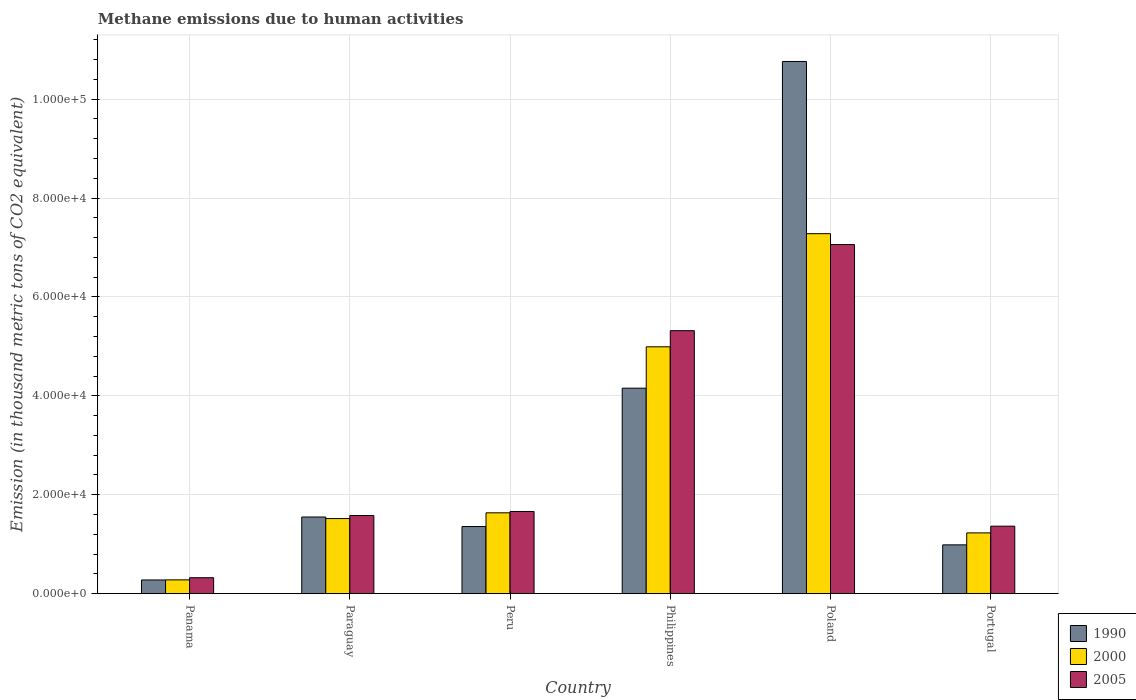Are the number of bars per tick equal to the number of legend labels?
Keep it short and to the point. Yes. What is the amount of methane emitted in 2005 in Panama?
Ensure brevity in your answer.  3225.9. Across all countries, what is the maximum amount of methane emitted in 2005?
Provide a succinct answer. 7.06e+04. Across all countries, what is the minimum amount of methane emitted in 2000?
Your answer should be compact. 2789.9. In which country was the amount of methane emitted in 2005 minimum?
Your answer should be compact. Panama. What is the total amount of methane emitted in 1990 in the graph?
Offer a very short reply. 1.91e+05. What is the difference between the amount of methane emitted in 2000 in Peru and that in Poland?
Provide a succinct answer. -5.64e+04. What is the difference between the amount of methane emitted in 2005 in Philippines and the amount of methane emitted in 2000 in Paraguay?
Offer a very short reply. 3.80e+04. What is the average amount of methane emitted in 2005 per country?
Keep it short and to the point. 2.88e+04. What is the difference between the amount of methane emitted of/in 2000 and amount of methane emitted of/in 1990 in Peru?
Your response must be concise. 2771.4. What is the ratio of the amount of methane emitted in 2000 in Poland to that in Portugal?
Keep it short and to the point. 5.92. Is the amount of methane emitted in 2000 in Paraguay less than that in Philippines?
Give a very brief answer. Yes. Is the difference between the amount of methane emitted in 2000 in Paraguay and Peru greater than the difference between the amount of methane emitted in 1990 in Paraguay and Peru?
Ensure brevity in your answer.  No. What is the difference between the highest and the second highest amount of methane emitted in 2005?
Give a very brief answer. 5.40e+04. What is the difference between the highest and the lowest amount of methane emitted in 2000?
Keep it short and to the point. 7.00e+04. Is the sum of the amount of methane emitted in 2000 in Poland and Portugal greater than the maximum amount of methane emitted in 1990 across all countries?
Provide a succinct answer. No. Is it the case that in every country, the sum of the amount of methane emitted in 2005 and amount of methane emitted in 2000 is greater than the amount of methane emitted in 1990?
Provide a short and direct response. Yes. How many bars are there?
Your answer should be compact. 18. Does the graph contain grids?
Provide a succinct answer. Yes. Where does the legend appear in the graph?
Provide a short and direct response. Bottom right. How are the legend labels stacked?
Keep it short and to the point. Vertical. What is the title of the graph?
Make the answer very short. Methane emissions due to human activities. Does "2011" appear as one of the legend labels in the graph?
Keep it short and to the point. No. What is the label or title of the Y-axis?
Give a very brief answer. Emission (in thousand metric tons of CO2 equivalent). What is the Emission (in thousand metric tons of CO2 equivalent) of 1990 in Panama?
Provide a succinct answer. 2769.4. What is the Emission (in thousand metric tons of CO2 equivalent) in 2000 in Panama?
Provide a succinct answer. 2789.9. What is the Emission (in thousand metric tons of CO2 equivalent) of 2005 in Panama?
Your answer should be compact. 3225.9. What is the Emission (in thousand metric tons of CO2 equivalent) in 1990 in Paraguay?
Offer a terse response. 1.55e+04. What is the Emission (in thousand metric tons of CO2 equivalent) in 2000 in Paraguay?
Keep it short and to the point. 1.52e+04. What is the Emission (in thousand metric tons of CO2 equivalent) in 2005 in Paraguay?
Your answer should be very brief. 1.58e+04. What is the Emission (in thousand metric tons of CO2 equivalent) in 1990 in Peru?
Provide a short and direct response. 1.36e+04. What is the Emission (in thousand metric tons of CO2 equivalent) of 2000 in Peru?
Your answer should be compact. 1.63e+04. What is the Emission (in thousand metric tons of CO2 equivalent) of 2005 in Peru?
Ensure brevity in your answer.  1.66e+04. What is the Emission (in thousand metric tons of CO2 equivalent) in 1990 in Philippines?
Make the answer very short. 4.16e+04. What is the Emission (in thousand metric tons of CO2 equivalent) in 2000 in Philippines?
Your answer should be very brief. 4.99e+04. What is the Emission (in thousand metric tons of CO2 equivalent) in 2005 in Philippines?
Make the answer very short. 5.32e+04. What is the Emission (in thousand metric tons of CO2 equivalent) of 1990 in Poland?
Your response must be concise. 1.08e+05. What is the Emission (in thousand metric tons of CO2 equivalent) of 2000 in Poland?
Make the answer very short. 7.28e+04. What is the Emission (in thousand metric tons of CO2 equivalent) in 2005 in Poland?
Give a very brief answer. 7.06e+04. What is the Emission (in thousand metric tons of CO2 equivalent) in 1990 in Portugal?
Offer a terse response. 9868.6. What is the Emission (in thousand metric tons of CO2 equivalent) in 2000 in Portugal?
Your answer should be very brief. 1.23e+04. What is the Emission (in thousand metric tons of CO2 equivalent) of 2005 in Portugal?
Offer a very short reply. 1.36e+04. Across all countries, what is the maximum Emission (in thousand metric tons of CO2 equivalent) in 1990?
Your answer should be very brief. 1.08e+05. Across all countries, what is the maximum Emission (in thousand metric tons of CO2 equivalent) in 2000?
Make the answer very short. 7.28e+04. Across all countries, what is the maximum Emission (in thousand metric tons of CO2 equivalent) of 2005?
Provide a succinct answer. 7.06e+04. Across all countries, what is the minimum Emission (in thousand metric tons of CO2 equivalent) of 1990?
Your answer should be very brief. 2769.4. Across all countries, what is the minimum Emission (in thousand metric tons of CO2 equivalent) of 2000?
Provide a succinct answer. 2789.9. Across all countries, what is the minimum Emission (in thousand metric tons of CO2 equivalent) of 2005?
Your response must be concise. 3225.9. What is the total Emission (in thousand metric tons of CO2 equivalent) in 1990 in the graph?
Offer a very short reply. 1.91e+05. What is the total Emission (in thousand metric tons of CO2 equivalent) in 2000 in the graph?
Your answer should be compact. 1.69e+05. What is the total Emission (in thousand metric tons of CO2 equivalent) of 2005 in the graph?
Ensure brevity in your answer.  1.73e+05. What is the difference between the Emission (in thousand metric tons of CO2 equivalent) of 1990 in Panama and that in Paraguay?
Your answer should be compact. -1.27e+04. What is the difference between the Emission (in thousand metric tons of CO2 equivalent) in 2000 in Panama and that in Paraguay?
Give a very brief answer. -1.24e+04. What is the difference between the Emission (in thousand metric tons of CO2 equivalent) of 2005 in Panama and that in Paraguay?
Provide a succinct answer. -1.26e+04. What is the difference between the Emission (in thousand metric tons of CO2 equivalent) of 1990 in Panama and that in Peru?
Ensure brevity in your answer.  -1.08e+04. What is the difference between the Emission (in thousand metric tons of CO2 equivalent) of 2000 in Panama and that in Peru?
Offer a terse response. -1.36e+04. What is the difference between the Emission (in thousand metric tons of CO2 equivalent) in 2005 in Panama and that in Peru?
Provide a short and direct response. -1.34e+04. What is the difference between the Emission (in thousand metric tons of CO2 equivalent) of 1990 in Panama and that in Philippines?
Your answer should be compact. -3.88e+04. What is the difference between the Emission (in thousand metric tons of CO2 equivalent) of 2000 in Panama and that in Philippines?
Provide a succinct answer. -4.71e+04. What is the difference between the Emission (in thousand metric tons of CO2 equivalent) in 2005 in Panama and that in Philippines?
Offer a terse response. -4.99e+04. What is the difference between the Emission (in thousand metric tons of CO2 equivalent) in 1990 in Panama and that in Poland?
Make the answer very short. -1.05e+05. What is the difference between the Emission (in thousand metric tons of CO2 equivalent) in 2000 in Panama and that in Poland?
Give a very brief answer. -7.00e+04. What is the difference between the Emission (in thousand metric tons of CO2 equivalent) of 2005 in Panama and that in Poland?
Your answer should be compact. -6.74e+04. What is the difference between the Emission (in thousand metric tons of CO2 equivalent) in 1990 in Panama and that in Portugal?
Ensure brevity in your answer.  -7099.2. What is the difference between the Emission (in thousand metric tons of CO2 equivalent) of 2000 in Panama and that in Portugal?
Provide a short and direct response. -9499.2. What is the difference between the Emission (in thousand metric tons of CO2 equivalent) in 2005 in Panama and that in Portugal?
Offer a very short reply. -1.04e+04. What is the difference between the Emission (in thousand metric tons of CO2 equivalent) in 1990 in Paraguay and that in Peru?
Give a very brief answer. 1927.1. What is the difference between the Emission (in thousand metric tons of CO2 equivalent) of 2000 in Paraguay and that in Peru?
Make the answer very short. -1160.8. What is the difference between the Emission (in thousand metric tons of CO2 equivalent) in 2005 in Paraguay and that in Peru?
Give a very brief answer. -820.6. What is the difference between the Emission (in thousand metric tons of CO2 equivalent) in 1990 in Paraguay and that in Philippines?
Give a very brief answer. -2.61e+04. What is the difference between the Emission (in thousand metric tons of CO2 equivalent) of 2000 in Paraguay and that in Philippines?
Provide a succinct answer. -3.47e+04. What is the difference between the Emission (in thousand metric tons of CO2 equivalent) in 2005 in Paraguay and that in Philippines?
Your response must be concise. -3.74e+04. What is the difference between the Emission (in thousand metric tons of CO2 equivalent) in 1990 in Paraguay and that in Poland?
Provide a short and direct response. -9.21e+04. What is the difference between the Emission (in thousand metric tons of CO2 equivalent) in 2000 in Paraguay and that in Poland?
Give a very brief answer. -5.76e+04. What is the difference between the Emission (in thousand metric tons of CO2 equivalent) in 2005 in Paraguay and that in Poland?
Ensure brevity in your answer.  -5.48e+04. What is the difference between the Emission (in thousand metric tons of CO2 equivalent) in 1990 in Paraguay and that in Portugal?
Keep it short and to the point. 5632.2. What is the difference between the Emission (in thousand metric tons of CO2 equivalent) of 2000 in Paraguay and that in Portugal?
Offer a very short reply. 2895.2. What is the difference between the Emission (in thousand metric tons of CO2 equivalent) in 2005 in Paraguay and that in Portugal?
Make the answer very short. 2151.5. What is the difference between the Emission (in thousand metric tons of CO2 equivalent) in 1990 in Peru and that in Philippines?
Your answer should be very brief. -2.80e+04. What is the difference between the Emission (in thousand metric tons of CO2 equivalent) in 2000 in Peru and that in Philippines?
Keep it short and to the point. -3.36e+04. What is the difference between the Emission (in thousand metric tons of CO2 equivalent) of 2005 in Peru and that in Philippines?
Your answer should be very brief. -3.66e+04. What is the difference between the Emission (in thousand metric tons of CO2 equivalent) of 1990 in Peru and that in Poland?
Make the answer very short. -9.40e+04. What is the difference between the Emission (in thousand metric tons of CO2 equivalent) of 2000 in Peru and that in Poland?
Provide a succinct answer. -5.64e+04. What is the difference between the Emission (in thousand metric tons of CO2 equivalent) in 2005 in Peru and that in Poland?
Provide a short and direct response. -5.40e+04. What is the difference between the Emission (in thousand metric tons of CO2 equivalent) of 1990 in Peru and that in Portugal?
Offer a very short reply. 3705.1. What is the difference between the Emission (in thousand metric tons of CO2 equivalent) of 2000 in Peru and that in Portugal?
Your response must be concise. 4056. What is the difference between the Emission (in thousand metric tons of CO2 equivalent) of 2005 in Peru and that in Portugal?
Make the answer very short. 2972.1. What is the difference between the Emission (in thousand metric tons of CO2 equivalent) of 1990 in Philippines and that in Poland?
Offer a terse response. -6.61e+04. What is the difference between the Emission (in thousand metric tons of CO2 equivalent) in 2000 in Philippines and that in Poland?
Make the answer very short. -2.29e+04. What is the difference between the Emission (in thousand metric tons of CO2 equivalent) in 2005 in Philippines and that in Poland?
Provide a succinct answer. -1.74e+04. What is the difference between the Emission (in thousand metric tons of CO2 equivalent) of 1990 in Philippines and that in Portugal?
Make the answer very short. 3.17e+04. What is the difference between the Emission (in thousand metric tons of CO2 equivalent) in 2000 in Philippines and that in Portugal?
Your response must be concise. 3.76e+04. What is the difference between the Emission (in thousand metric tons of CO2 equivalent) of 2005 in Philippines and that in Portugal?
Your response must be concise. 3.95e+04. What is the difference between the Emission (in thousand metric tons of CO2 equivalent) of 1990 in Poland and that in Portugal?
Your response must be concise. 9.77e+04. What is the difference between the Emission (in thousand metric tons of CO2 equivalent) of 2000 in Poland and that in Portugal?
Your answer should be compact. 6.05e+04. What is the difference between the Emission (in thousand metric tons of CO2 equivalent) of 2005 in Poland and that in Portugal?
Offer a terse response. 5.69e+04. What is the difference between the Emission (in thousand metric tons of CO2 equivalent) in 1990 in Panama and the Emission (in thousand metric tons of CO2 equivalent) in 2000 in Paraguay?
Your response must be concise. -1.24e+04. What is the difference between the Emission (in thousand metric tons of CO2 equivalent) of 1990 in Panama and the Emission (in thousand metric tons of CO2 equivalent) of 2005 in Paraguay?
Your response must be concise. -1.30e+04. What is the difference between the Emission (in thousand metric tons of CO2 equivalent) in 2000 in Panama and the Emission (in thousand metric tons of CO2 equivalent) in 2005 in Paraguay?
Your answer should be compact. -1.30e+04. What is the difference between the Emission (in thousand metric tons of CO2 equivalent) of 1990 in Panama and the Emission (in thousand metric tons of CO2 equivalent) of 2000 in Peru?
Your answer should be very brief. -1.36e+04. What is the difference between the Emission (in thousand metric tons of CO2 equivalent) of 1990 in Panama and the Emission (in thousand metric tons of CO2 equivalent) of 2005 in Peru?
Offer a very short reply. -1.38e+04. What is the difference between the Emission (in thousand metric tons of CO2 equivalent) of 2000 in Panama and the Emission (in thousand metric tons of CO2 equivalent) of 2005 in Peru?
Your response must be concise. -1.38e+04. What is the difference between the Emission (in thousand metric tons of CO2 equivalent) of 1990 in Panama and the Emission (in thousand metric tons of CO2 equivalent) of 2000 in Philippines?
Give a very brief answer. -4.71e+04. What is the difference between the Emission (in thousand metric tons of CO2 equivalent) of 1990 in Panama and the Emission (in thousand metric tons of CO2 equivalent) of 2005 in Philippines?
Make the answer very short. -5.04e+04. What is the difference between the Emission (in thousand metric tons of CO2 equivalent) of 2000 in Panama and the Emission (in thousand metric tons of CO2 equivalent) of 2005 in Philippines?
Keep it short and to the point. -5.04e+04. What is the difference between the Emission (in thousand metric tons of CO2 equivalent) of 1990 in Panama and the Emission (in thousand metric tons of CO2 equivalent) of 2000 in Poland?
Your answer should be very brief. -7.00e+04. What is the difference between the Emission (in thousand metric tons of CO2 equivalent) of 1990 in Panama and the Emission (in thousand metric tons of CO2 equivalent) of 2005 in Poland?
Give a very brief answer. -6.78e+04. What is the difference between the Emission (in thousand metric tons of CO2 equivalent) of 2000 in Panama and the Emission (in thousand metric tons of CO2 equivalent) of 2005 in Poland?
Offer a very short reply. -6.78e+04. What is the difference between the Emission (in thousand metric tons of CO2 equivalent) in 1990 in Panama and the Emission (in thousand metric tons of CO2 equivalent) in 2000 in Portugal?
Offer a very short reply. -9519.7. What is the difference between the Emission (in thousand metric tons of CO2 equivalent) in 1990 in Panama and the Emission (in thousand metric tons of CO2 equivalent) in 2005 in Portugal?
Make the answer very short. -1.09e+04. What is the difference between the Emission (in thousand metric tons of CO2 equivalent) of 2000 in Panama and the Emission (in thousand metric tons of CO2 equivalent) of 2005 in Portugal?
Offer a very short reply. -1.09e+04. What is the difference between the Emission (in thousand metric tons of CO2 equivalent) of 1990 in Paraguay and the Emission (in thousand metric tons of CO2 equivalent) of 2000 in Peru?
Make the answer very short. -844.3. What is the difference between the Emission (in thousand metric tons of CO2 equivalent) in 1990 in Paraguay and the Emission (in thousand metric tons of CO2 equivalent) in 2005 in Peru?
Offer a terse response. -1118.2. What is the difference between the Emission (in thousand metric tons of CO2 equivalent) of 2000 in Paraguay and the Emission (in thousand metric tons of CO2 equivalent) of 2005 in Peru?
Provide a short and direct response. -1434.7. What is the difference between the Emission (in thousand metric tons of CO2 equivalent) in 1990 in Paraguay and the Emission (in thousand metric tons of CO2 equivalent) in 2000 in Philippines?
Keep it short and to the point. -3.44e+04. What is the difference between the Emission (in thousand metric tons of CO2 equivalent) in 1990 in Paraguay and the Emission (in thousand metric tons of CO2 equivalent) in 2005 in Philippines?
Offer a terse response. -3.77e+04. What is the difference between the Emission (in thousand metric tons of CO2 equivalent) of 2000 in Paraguay and the Emission (in thousand metric tons of CO2 equivalent) of 2005 in Philippines?
Your response must be concise. -3.80e+04. What is the difference between the Emission (in thousand metric tons of CO2 equivalent) of 1990 in Paraguay and the Emission (in thousand metric tons of CO2 equivalent) of 2000 in Poland?
Ensure brevity in your answer.  -5.73e+04. What is the difference between the Emission (in thousand metric tons of CO2 equivalent) of 1990 in Paraguay and the Emission (in thousand metric tons of CO2 equivalent) of 2005 in Poland?
Keep it short and to the point. -5.51e+04. What is the difference between the Emission (in thousand metric tons of CO2 equivalent) of 2000 in Paraguay and the Emission (in thousand metric tons of CO2 equivalent) of 2005 in Poland?
Your answer should be very brief. -5.54e+04. What is the difference between the Emission (in thousand metric tons of CO2 equivalent) of 1990 in Paraguay and the Emission (in thousand metric tons of CO2 equivalent) of 2000 in Portugal?
Ensure brevity in your answer.  3211.7. What is the difference between the Emission (in thousand metric tons of CO2 equivalent) of 1990 in Paraguay and the Emission (in thousand metric tons of CO2 equivalent) of 2005 in Portugal?
Provide a short and direct response. 1853.9. What is the difference between the Emission (in thousand metric tons of CO2 equivalent) in 2000 in Paraguay and the Emission (in thousand metric tons of CO2 equivalent) in 2005 in Portugal?
Your answer should be very brief. 1537.4. What is the difference between the Emission (in thousand metric tons of CO2 equivalent) of 1990 in Peru and the Emission (in thousand metric tons of CO2 equivalent) of 2000 in Philippines?
Provide a short and direct response. -3.63e+04. What is the difference between the Emission (in thousand metric tons of CO2 equivalent) of 1990 in Peru and the Emission (in thousand metric tons of CO2 equivalent) of 2005 in Philippines?
Offer a terse response. -3.96e+04. What is the difference between the Emission (in thousand metric tons of CO2 equivalent) of 2000 in Peru and the Emission (in thousand metric tons of CO2 equivalent) of 2005 in Philippines?
Ensure brevity in your answer.  -3.68e+04. What is the difference between the Emission (in thousand metric tons of CO2 equivalent) in 1990 in Peru and the Emission (in thousand metric tons of CO2 equivalent) in 2000 in Poland?
Offer a terse response. -5.92e+04. What is the difference between the Emission (in thousand metric tons of CO2 equivalent) of 1990 in Peru and the Emission (in thousand metric tons of CO2 equivalent) of 2005 in Poland?
Your answer should be very brief. -5.70e+04. What is the difference between the Emission (in thousand metric tons of CO2 equivalent) of 2000 in Peru and the Emission (in thousand metric tons of CO2 equivalent) of 2005 in Poland?
Provide a succinct answer. -5.42e+04. What is the difference between the Emission (in thousand metric tons of CO2 equivalent) of 1990 in Peru and the Emission (in thousand metric tons of CO2 equivalent) of 2000 in Portugal?
Your response must be concise. 1284.6. What is the difference between the Emission (in thousand metric tons of CO2 equivalent) of 1990 in Peru and the Emission (in thousand metric tons of CO2 equivalent) of 2005 in Portugal?
Your response must be concise. -73.2. What is the difference between the Emission (in thousand metric tons of CO2 equivalent) of 2000 in Peru and the Emission (in thousand metric tons of CO2 equivalent) of 2005 in Portugal?
Offer a very short reply. 2698.2. What is the difference between the Emission (in thousand metric tons of CO2 equivalent) in 1990 in Philippines and the Emission (in thousand metric tons of CO2 equivalent) in 2000 in Poland?
Your response must be concise. -3.12e+04. What is the difference between the Emission (in thousand metric tons of CO2 equivalent) of 1990 in Philippines and the Emission (in thousand metric tons of CO2 equivalent) of 2005 in Poland?
Provide a short and direct response. -2.90e+04. What is the difference between the Emission (in thousand metric tons of CO2 equivalent) in 2000 in Philippines and the Emission (in thousand metric tons of CO2 equivalent) in 2005 in Poland?
Your answer should be compact. -2.07e+04. What is the difference between the Emission (in thousand metric tons of CO2 equivalent) in 1990 in Philippines and the Emission (in thousand metric tons of CO2 equivalent) in 2000 in Portugal?
Provide a succinct answer. 2.93e+04. What is the difference between the Emission (in thousand metric tons of CO2 equivalent) of 1990 in Philippines and the Emission (in thousand metric tons of CO2 equivalent) of 2005 in Portugal?
Your answer should be compact. 2.79e+04. What is the difference between the Emission (in thousand metric tons of CO2 equivalent) in 2000 in Philippines and the Emission (in thousand metric tons of CO2 equivalent) in 2005 in Portugal?
Offer a terse response. 3.63e+04. What is the difference between the Emission (in thousand metric tons of CO2 equivalent) of 1990 in Poland and the Emission (in thousand metric tons of CO2 equivalent) of 2000 in Portugal?
Your answer should be very brief. 9.53e+04. What is the difference between the Emission (in thousand metric tons of CO2 equivalent) of 1990 in Poland and the Emission (in thousand metric tons of CO2 equivalent) of 2005 in Portugal?
Your answer should be very brief. 9.40e+04. What is the difference between the Emission (in thousand metric tons of CO2 equivalent) of 2000 in Poland and the Emission (in thousand metric tons of CO2 equivalent) of 2005 in Portugal?
Your response must be concise. 5.91e+04. What is the average Emission (in thousand metric tons of CO2 equivalent) in 1990 per country?
Your answer should be very brief. 3.18e+04. What is the average Emission (in thousand metric tons of CO2 equivalent) in 2000 per country?
Offer a terse response. 2.82e+04. What is the average Emission (in thousand metric tons of CO2 equivalent) in 2005 per country?
Provide a succinct answer. 2.88e+04. What is the difference between the Emission (in thousand metric tons of CO2 equivalent) of 1990 and Emission (in thousand metric tons of CO2 equivalent) of 2000 in Panama?
Make the answer very short. -20.5. What is the difference between the Emission (in thousand metric tons of CO2 equivalent) of 1990 and Emission (in thousand metric tons of CO2 equivalent) of 2005 in Panama?
Offer a very short reply. -456.5. What is the difference between the Emission (in thousand metric tons of CO2 equivalent) in 2000 and Emission (in thousand metric tons of CO2 equivalent) in 2005 in Panama?
Your response must be concise. -436. What is the difference between the Emission (in thousand metric tons of CO2 equivalent) of 1990 and Emission (in thousand metric tons of CO2 equivalent) of 2000 in Paraguay?
Your response must be concise. 316.5. What is the difference between the Emission (in thousand metric tons of CO2 equivalent) in 1990 and Emission (in thousand metric tons of CO2 equivalent) in 2005 in Paraguay?
Provide a short and direct response. -297.6. What is the difference between the Emission (in thousand metric tons of CO2 equivalent) of 2000 and Emission (in thousand metric tons of CO2 equivalent) of 2005 in Paraguay?
Your answer should be compact. -614.1. What is the difference between the Emission (in thousand metric tons of CO2 equivalent) in 1990 and Emission (in thousand metric tons of CO2 equivalent) in 2000 in Peru?
Provide a short and direct response. -2771.4. What is the difference between the Emission (in thousand metric tons of CO2 equivalent) of 1990 and Emission (in thousand metric tons of CO2 equivalent) of 2005 in Peru?
Give a very brief answer. -3045.3. What is the difference between the Emission (in thousand metric tons of CO2 equivalent) in 2000 and Emission (in thousand metric tons of CO2 equivalent) in 2005 in Peru?
Your answer should be compact. -273.9. What is the difference between the Emission (in thousand metric tons of CO2 equivalent) in 1990 and Emission (in thousand metric tons of CO2 equivalent) in 2000 in Philippines?
Ensure brevity in your answer.  -8363.6. What is the difference between the Emission (in thousand metric tons of CO2 equivalent) of 1990 and Emission (in thousand metric tons of CO2 equivalent) of 2005 in Philippines?
Your answer should be very brief. -1.16e+04. What is the difference between the Emission (in thousand metric tons of CO2 equivalent) in 2000 and Emission (in thousand metric tons of CO2 equivalent) in 2005 in Philippines?
Provide a short and direct response. -3260.6. What is the difference between the Emission (in thousand metric tons of CO2 equivalent) of 1990 and Emission (in thousand metric tons of CO2 equivalent) of 2000 in Poland?
Provide a short and direct response. 3.48e+04. What is the difference between the Emission (in thousand metric tons of CO2 equivalent) in 1990 and Emission (in thousand metric tons of CO2 equivalent) in 2005 in Poland?
Provide a succinct answer. 3.70e+04. What is the difference between the Emission (in thousand metric tons of CO2 equivalent) of 2000 and Emission (in thousand metric tons of CO2 equivalent) of 2005 in Poland?
Ensure brevity in your answer.  2197.9. What is the difference between the Emission (in thousand metric tons of CO2 equivalent) in 1990 and Emission (in thousand metric tons of CO2 equivalent) in 2000 in Portugal?
Your answer should be very brief. -2420.5. What is the difference between the Emission (in thousand metric tons of CO2 equivalent) of 1990 and Emission (in thousand metric tons of CO2 equivalent) of 2005 in Portugal?
Provide a short and direct response. -3778.3. What is the difference between the Emission (in thousand metric tons of CO2 equivalent) in 2000 and Emission (in thousand metric tons of CO2 equivalent) in 2005 in Portugal?
Your response must be concise. -1357.8. What is the ratio of the Emission (in thousand metric tons of CO2 equivalent) of 1990 in Panama to that in Paraguay?
Provide a short and direct response. 0.18. What is the ratio of the Emission (in thousand metric tons of CO2 equivalent) in 2000 in Panama to that in Paraguay?
Offer a terse response. 0.18. What is the ratio of the Emission (in thousand metric tons of CO2 equivalent) in 2005 in Panama to that in Paraguay?
Your answer should be compact. 0.2. What is the ratio of the Emission (in thousand metric tons of CO2 equivalent) in 1990 in Panama to that in Peru?
Offer a very short reply. 0.2. What is the ratio of the Emission (in thousand metric tons of CO2 equivalent) in 2000 in Panama to that in Peru?
Ensure brevity in your answer.  0.17. What is the ratio of the Emission (in thousand metric tons of CO2 equivalent) of 2005 in Panama to that in Peru?
Offer a very short reply. 0.19. What is the ratio of the Emission (in thousand metric tons of CO2 equivalent) in 1990 in Panama to that in Philippines?
Provide a short and direct response. 0.07. What is the ratio of the Emission (in thousand metric tons of CO2 equivalent) of 2000 in Panama to that in Philippines?
Offer a terse response. 0.06. What is the ratio of the Emission (in thousand metric tons of CO2 equivalent) of 2005 in Panama to that in Philippines?
Keep it short and to the point. 0.06. What is the ratio of the Emission (in thousand metric tons of CO2 equivalent) of 1990 in Panama to that in Poland?
Keep it short and to the point. 0.03. What is the ratio of the Emission (in thousand metric tons of CO2 equivalent) in 2000 in Panama to that in Poland?
Your answer should be compact. 0.04. What is the ratio of the Emission (in thousand metric tons of CO2 equivalent) in 2005 in Panama to that in Poland?
Provide a short and direct response. 0.05. What is the ratio of the Emission (in thousand metric tons of CO2 equivalent) of 1990 in Panama to that in Portugal?
Offer a terse response. 0.28. What is the ratio of the Emission (in thousand metric tons of CO2 equivalent) of 2000 in Panama to that in Portugal?
Keep it short and to the point. 0.23. What is the ratio of the Emission (in thousand metric tons of CO2 equivalent) of 2005 in Panama to that in Portugal?
Offer a terse response. 0.24. What is the ratio of the Emission (in thousand metric tons of CO2 equivalent) in 1990 in Paraguay to that in Peru?
Ensure brevity in your answer.  1.14. What is the ratio of the Emission (in thousand metric tons of CO2 equivalent) in 2000 in Paraguay to that in Peru?
Your response must be concise. 0.93. What is the ratio of the Emission (in thousand metric tons of CO2 equivalent) of 2005 in Paraguay to that in Peru?
Your answer should be compact. 0.95. What is the ratio of the Emission (in thousand metric tons of CO2 equivalent) of 1990 in Paraguay to that in Philippines?
Give a very brief answer. 0.37. What is the ratio of the Emission (in thousand metric tons of CO2 equivalent) in 2000 in Paraguay to that in Philippines?
Offer a very short reply. 0.3. What is the ratio of the Emission (in thousand metric tons of CO2 equivalent) in 2005 in Paraguay to that in Philippines?
Offer a terse response. 0.3. What is the ratio of the Emission (in thousand metric tons of CO2 equivalent) in 1990 in Paraguay to that in Poland?
Your response must be concise. 0.14. What is the ratio of the Emission (in thousand metric tons of CO2 equivalent) of 2000 in Paraguay to that in Poland?
Give a very brief answer. 0.21. What is the ratio of the Emission (in thousand metric tons of CO2 equivalent) in 2005 in Paraguay to that in Poland?
Your response must be concise. 0.22. What is the ratio of the Emission (in thousand metric tons of CO2 equivalent) in 1990 in Paraguay to that in Portugal?
Make the answer very short. 1.57. What is the ratio of the Emission (in thousand metric tons of CO2 equivalent) of 2000 in Paraguay to that in Portugal?
Provide a short and direct response. 1.24. What is the ratio of the Emission (in thousand metric tons of CO2 equivalent) in 2005 in Paraguay to that in Portugal?
Offer a terse response. 1.16. What is the ratio of the Emission (in thousand metric tons of CO2 equivalent) in 1990 in Peru to that in Philippines?
Provide a succinct answer. 0.33. What is the ratio of the Emission (in thousand metric tons of CO2 equivalent) of 2000 in Peru to that in Philippines?
Provide a succinct answer. 0.33. What is the ratio of the Emission (in thousand metric tons of CO2 equivalent) of 2005 in Peru to that in Philippines?
Make the answer very short. 0.31. What is the ratio of the Emission (in thousand metric tons of CO2 equivalent) in 1990 in Peru to that in Poland?
Your answer should be very brief. 0.13. What is the ratio of the Emission (in thousand metric tons of CO2 equivalent) in 2000 in Peru to that in Poland?
Give a very brief answer. 0.22. What is the ratio of the Emission (in thousand metric tons of CO2 equivalent) of 2005 in Peru to that in Poland?
Offer a very short reply. 0.24. What is the ratio of the Emission (in thousand metric tons of CO2 equivalent) in 1990 in Peru to that in Portugal?
Your response must be concise. 1.38. What is the ratio of the Emission (in thousand metric tons of CO2 equivalent) of 2000 in Peru to that in Portugal?
Your answer should be very brief. 1.33. What is the ratio of the Emission (in thousand metric tons of CO2 equivalent) of 2005 in Peru to that in Portugal?
Ensure brevity in your answer.  1.22. What is the ratio of the Emission (in thousand metric tons of CO2 equivalent) of 1990 in Philippines to that in Poland?
Your answer should be compact. 0.39. What is the ratio of the Emission (in thousand metric tons of CO2 equivalent) in 2000 in Philippines to that in Poland?
Provide a succinct answer. 0.69. What is the ratio of the Emission (in thousand metric tons of CO2 equivalent) in 2005 in Philippines to that in Poland?
Provide a succinct answer. 0.75. What is the ratio of the Emission (in thousand metric tons of CO2 equivalent) in 1990 in Philippines to that in Portugal?
Your answer should be compact. 4.21. What is the ratio of the Emission (in thousand metric tons of CO2 equivalent) of 2000 in Philippines to that in Portugal?
Your response must be concise. 4.06. What is the ratio of the Emission (in thousand metric tons of CO2 equivalent) in 2005 in Philippines to that in Portugal?
Provide a succinct answer. 3.9. What is the ratio of the Emission (in thousand metric tons of CO2 equivalent) of 1990 in Poland to that in Portugal?
Your answer should be compact. 10.9. What is the ratio of the Emission (in thousand metric tons of CO2 equivalent) of 2000 in Poland to that in Portugal?
Offer a very short reply. 5.92. What is the ratio of the Emission (in thousand metric tons of CO2 equivalent) in 2005 in Poland to that in Portugal?
Keep it short and to the point. 5.17. What is the difference between the highest and the second highest Emission (in thousand metric tons of CO2 equivalent) of 1990?
Offer a very short reply. 6.61e+04. What is the difference between the highest and the second highest Emission (in thousand metric tons of CO2 equivalent) of 2000?
Your answer should be very brief. 2.29e+04. What is the difference between the highest and the second highest Emission (in thousand metric tons of CO2 equivalent) in 2005?
Give a very brief answer. 1.74e+04. What is the difference between the highest and the lowest Emission (in thousand metric tons of CO2 equivalent) of 1990?
Provide a succinct answer. 1.05e+05. What is the difference between the highest and the lowest Emission (in thousand metric tons of CO2 equivalent) of 2000?
Your answer should be compact. 7.00e+04. What is the difference between the highest and the lowest Emission (in thousand metric tons of CO2 equivalent) of 2005?
Your answer should be very brief. 6.74e+04. 